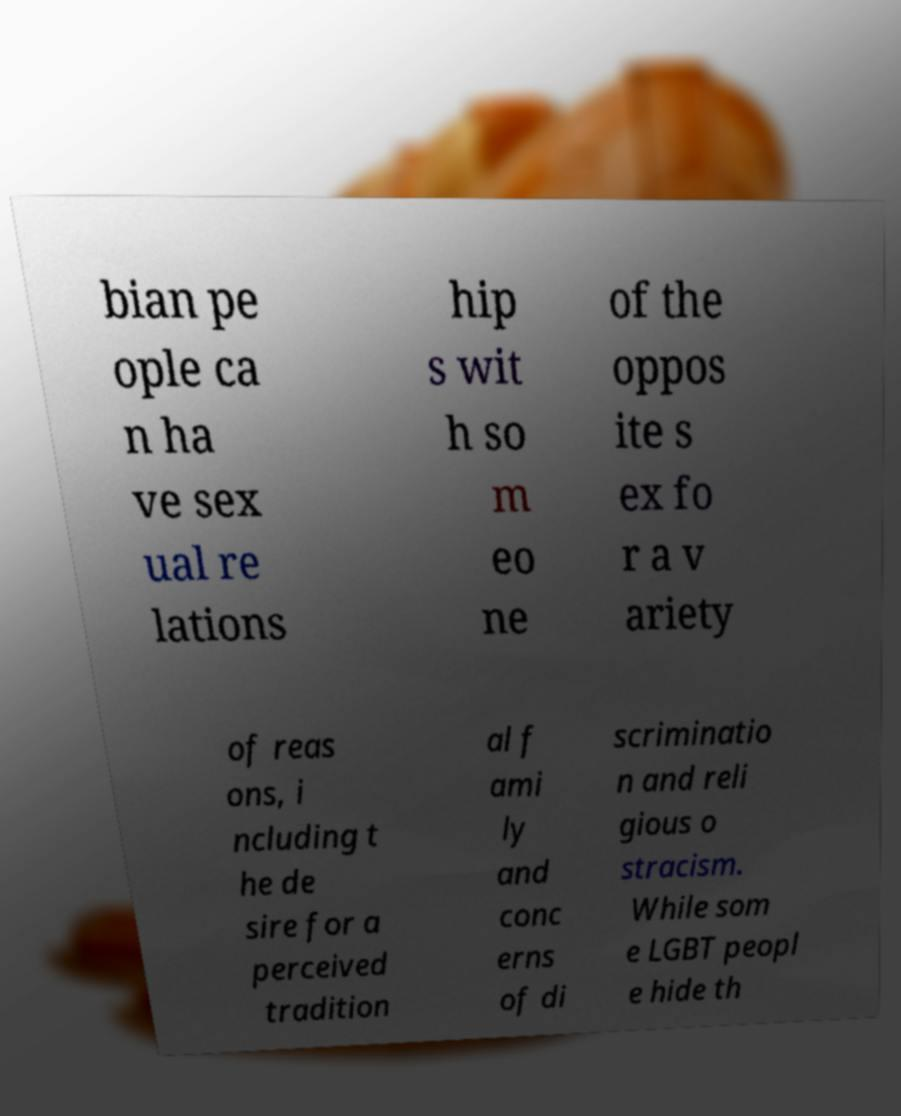There's text embedded in this image that I need extracted. Can you transcribe it verbatim? bian pe ople ca n ha ve sex ual re lations hip s wit h so m eo ne of the oppos ite s ex fo r a v ariety of reas ons, i ncluding t he de sire for a perceived tradition al f ami ly and conc erns of di scriminatio n and reli gious o stracism. While som e LGBT peopl e hide th 